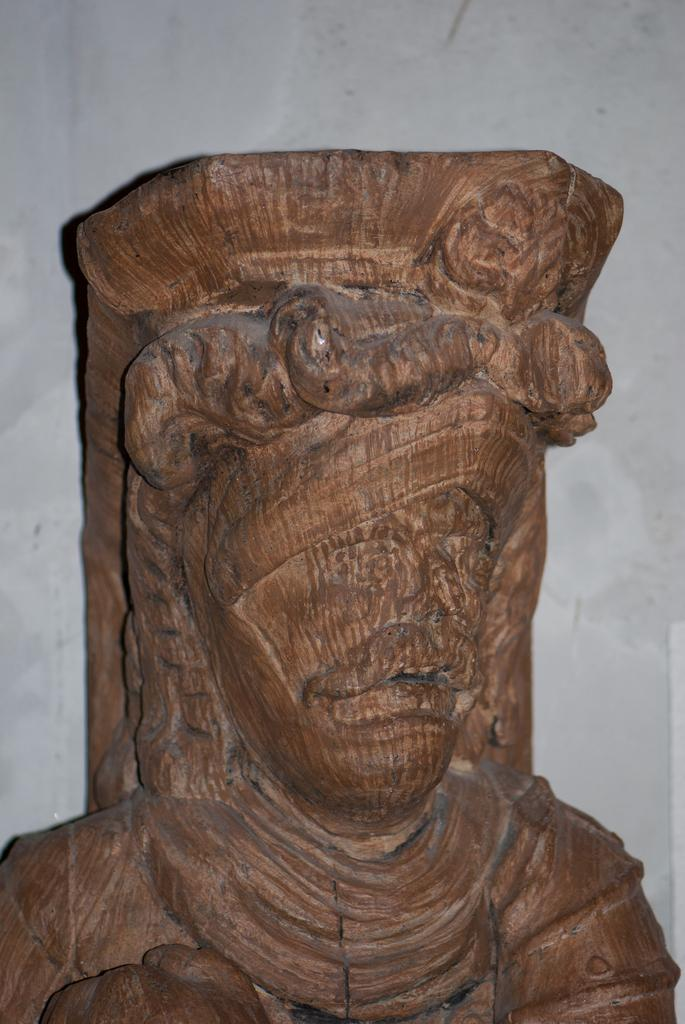What type of object is the main subject of the image? There is a wooden sculpture in the image. Can you describe the shape of the wooden sculpture? The sculpture is in the shape of a person. What color is the background of the image? The background of the image is white. How many horns does the person in the wooden sculpture have? There are no horns present on the person in the wooden sculpture; it is a sculpture of a person without any additional features. 